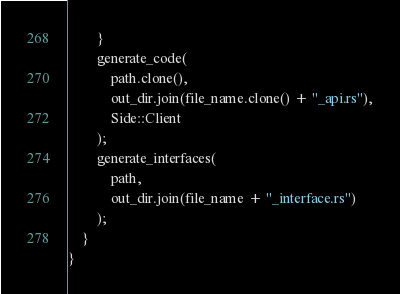Convert code to text. <code><loc_0><loc_0><loc_500><loc_500><_Rust_>        }
        generate_code(
            path.clone(),
            out_dir.join(file_name.clone() + "_api.rs"),
            Side::Client
        );
        generate_interfaces(
            path,
            out_dir.join(file_name + "_interface.rs")
        );
    }
}
</code> 